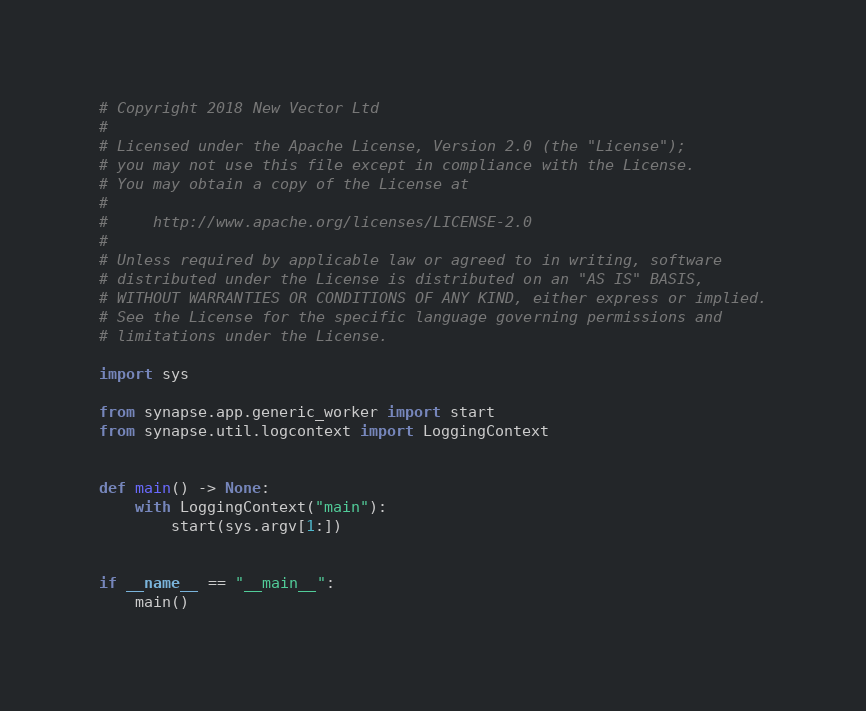<code> <loc_0><loc_0><loc_500><loc_500><_Python_># Copyright 2018 New Vector Ltd
#
# Licensed under the Apache License, Version 2.0 (the "License");
# you may not use this file except in compliance with the License.
# You may obtain a copy of the License at
#
#     http://www.apache.org/licenses/LICENSE-2.0
#
# Unless required by applicable law or agreed to in writing, software
# distributed under the License is distributed on an "AS IS" BASIS,
# WITHOUT WARRANTIES OR CONDITIONS OF ANY KIND, either express or implied.
# See the License for the specific language governing permissions and
# limitations under the License.

import sys

from synapse.app.generic_worker import start
from synapse.util.logcontext import LoggingContext


def main() -> None:
    with LoggingContext("main"):
        start(sys.argv[1:])


if __name__ == "__main__":
    main()
</code> 